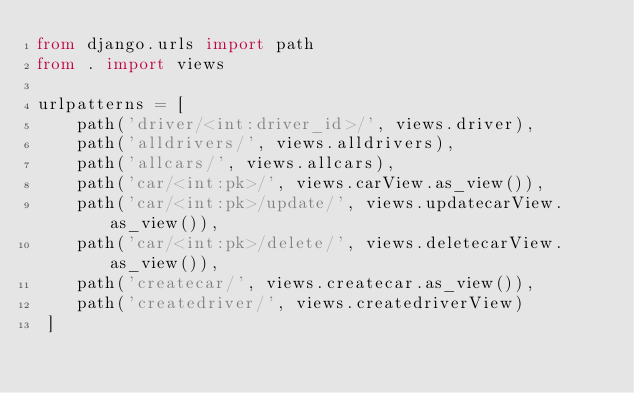Convert code to text. <code><loc_0><loc_0><loc_500><loc_500><_Python_>from django.urls import path
from . import views

urlpatterns = [
    path('driver/<int:driver_id>/', views.driver),
    path('alldrivers/', views.alldrivers),
    path('allcars/', views.allcars),
    path('car/<int:pk>/', views.carView.as_view()),
    path('car/<int:pk>/update/', views.updatecarView.as_view()),
    path('car/<int:pk>/delete/', views.deletecarView.as_view()),
    path('createcar/', views.createcar.as_view()),
    path('createdriver/', views.createdriverView)
 ]</code> 